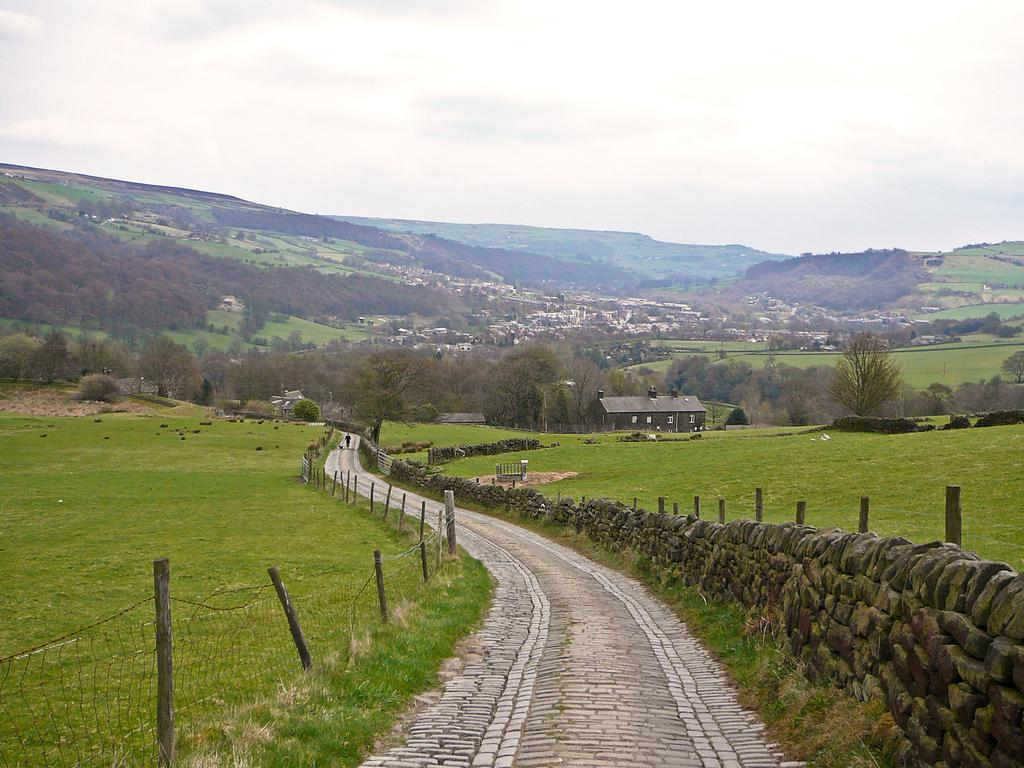What type of structures can be seen in the image? There are fences, sheds, and buildings in the image. What natural elements are present in the image? There are trees and hills in the image. What man-made objects can be seen in the image? There are poles in the image. What part of the environment is visible at the top of the image? The sky is visible at the top of the image. What part of the environment is visible at the bottom of the image? The ground is visible at the bottom of the image. What type of yarn is being used to decorate the trees in the image? There is no yarn present in the image; it features fences, sheds, trees, poles, buildings, hills, and the sky. Can you see any crackers being eaten by the animals in the image? There are no animals or crackers present in the image. 